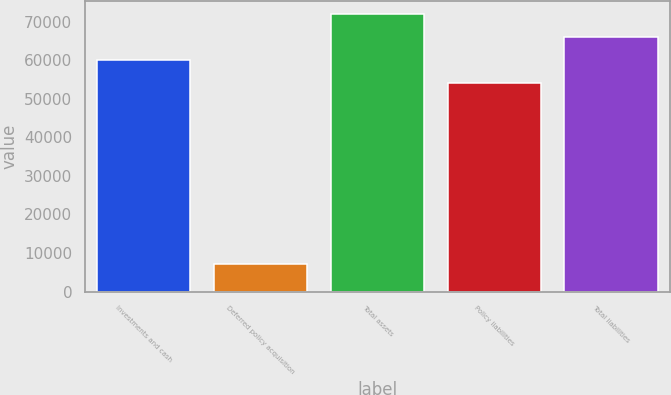<chart> <loc_0><loc_0><loc_500><loc_500><bar_chart><fcel>Investments and cash<fcel>Deferred policy acquisition<fcel>Total assets<fcel>Policy liabilities<fcel>Total liabilities<nl><fcel>60066.6<fcel>7094<fcel>71851.8<fcel>54174<fcel>65959.2<nl></chart> 